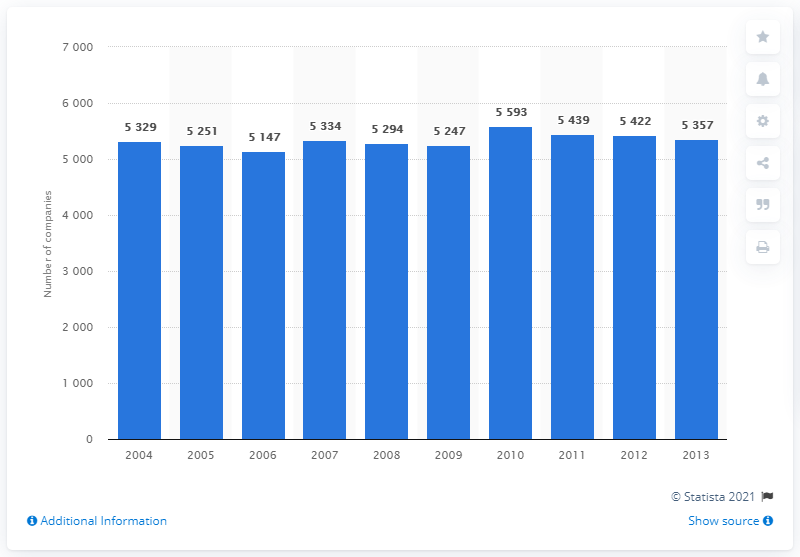Can you describe the trend in the number of companies in the insurance sector from 2004 to 2013? The trend shows that the number peaked in 2009 with 5,593 companies and saw a general decline thereafter, ending with 5,357 companies in 2013. 